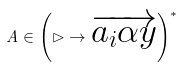Convert formula to latex. <formula><loc_0><loc_0><loc_500><loc_500>A \in \left ( \rhd \to \overrightarrow { a _ { i } \alpha y } \right ) ^ { * }</formula> 